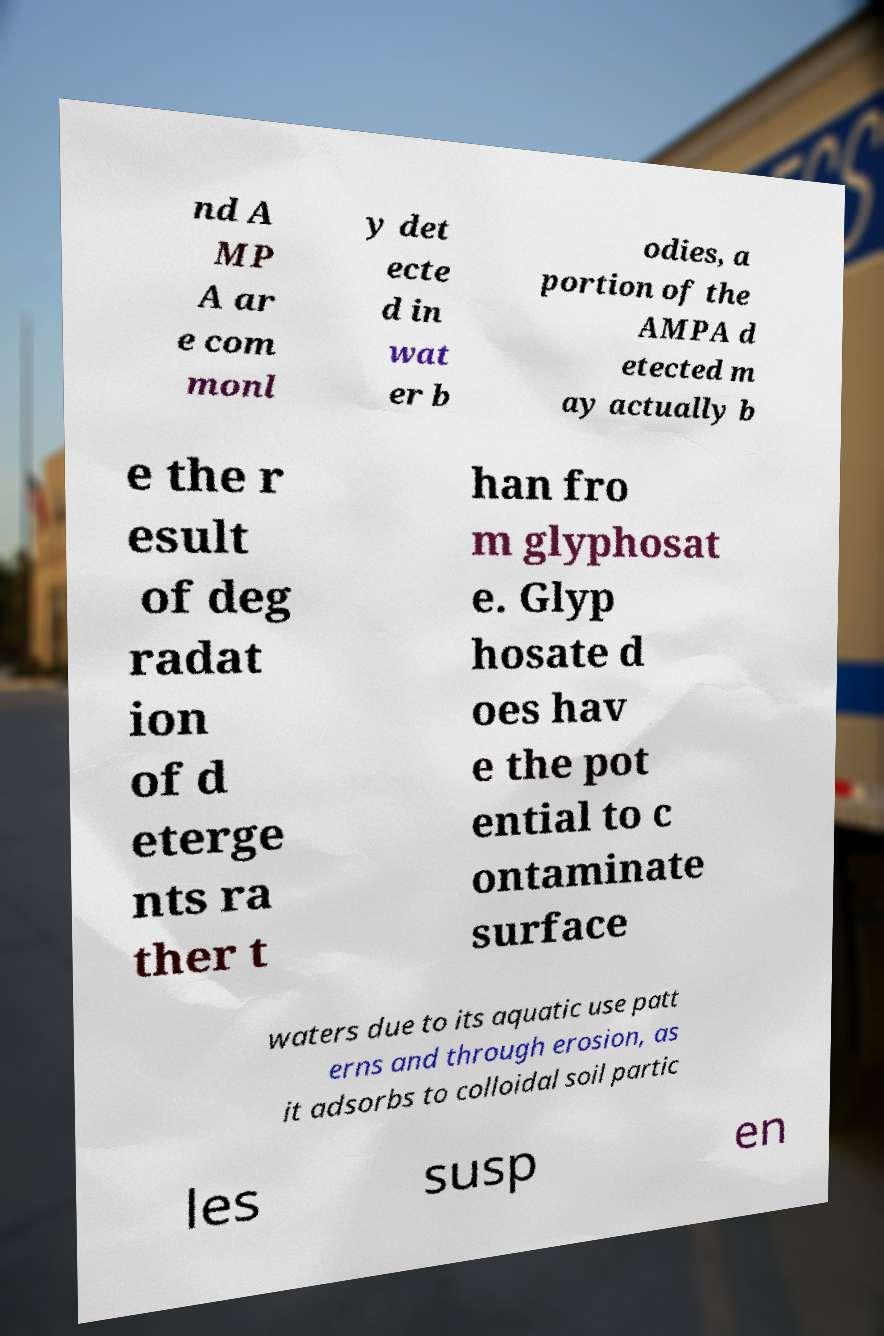What messages or text are displayed in this image? I need them in a readable, typed format. nd A MP A ar e com monl y det ecte d in wat er b odies, a portion of the AMPA d etected m ay actually b e the r esult of deg radat ion of d eterge nts ra ther t han fro m glyphosat e. Glyp hosate d oes hav e the pot ential to c ontaminate surface waters due to its aquatic use patt erns and through erosion, as it adsorbs to colloidal soil partic les susp en 